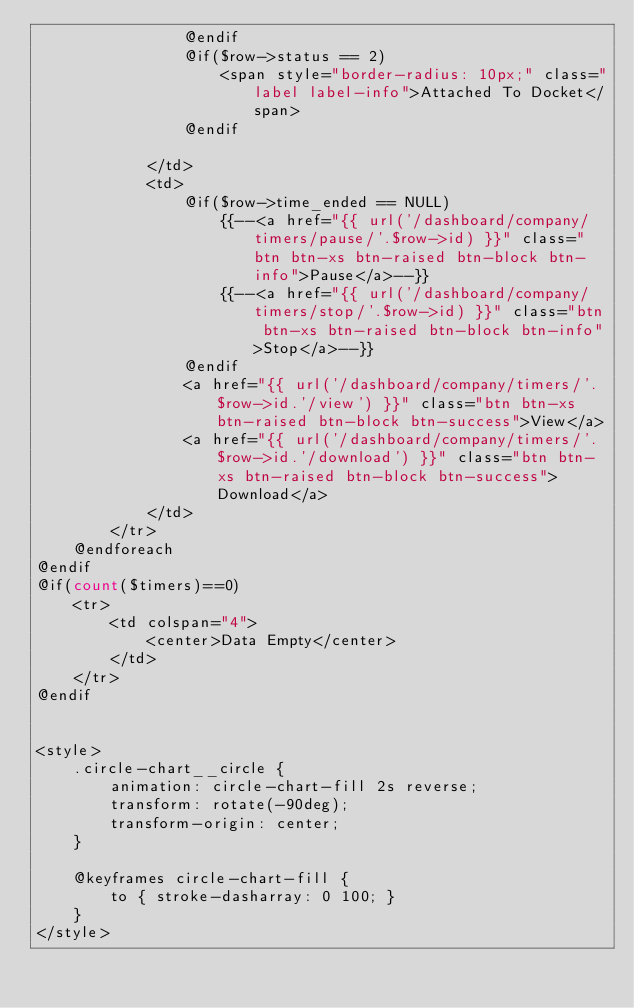<code> <loc_0><loc_0><loc_500><loc_500><_PHP_>                @endif
                @if($row->status == 2)
                    <span style="border-radius: 10px;" class="label label-info">Attached To Docket</span>
                @endif

            </td>
            <td>
                @if($row->time_ended == NULL)
                    {{--<a href="{{ url('/dashboard/company/timers/pause/'.$row->id) }}" class="btn btn-xs btn-raised btn-block btn-info">Pause</a>--}}
                    {{--<a href="{{ url('/dashboard/company/timers/stop/'.$row->id) }}" class="btn btn-xs btn-raised btn-block btn-info">Stop</a>--}}
                @endif
                <a href="{{ url('/dashboard/company/timers/'.$row->id.'/view') }}" class="btn btn-xs btn-raised btn-block btn-success">View</a>
                <a href="{{ url('/dashboard/company/timers/'.$row->id.'/download') }}" class="btn btn-xs btn-raised btn-block btn-success">Download</a>
            </td>
        </tr>
    @endforeach
@endif
@if(count($timers)==0)
    <tr>
        <td colspan="4">
            <center>Data Empty</center>
        </td>
    </tr>
@endif


<style>
    .circle-chart__circle {
        animation: circle-chart-fill 2s reverse;
        transform: rotate(-90deg);
        transform-origin: center;
    }

    @keyframes circle-chart-fill {
        to { stroke-dasharray: 0 100; }
    }
</style></code> 